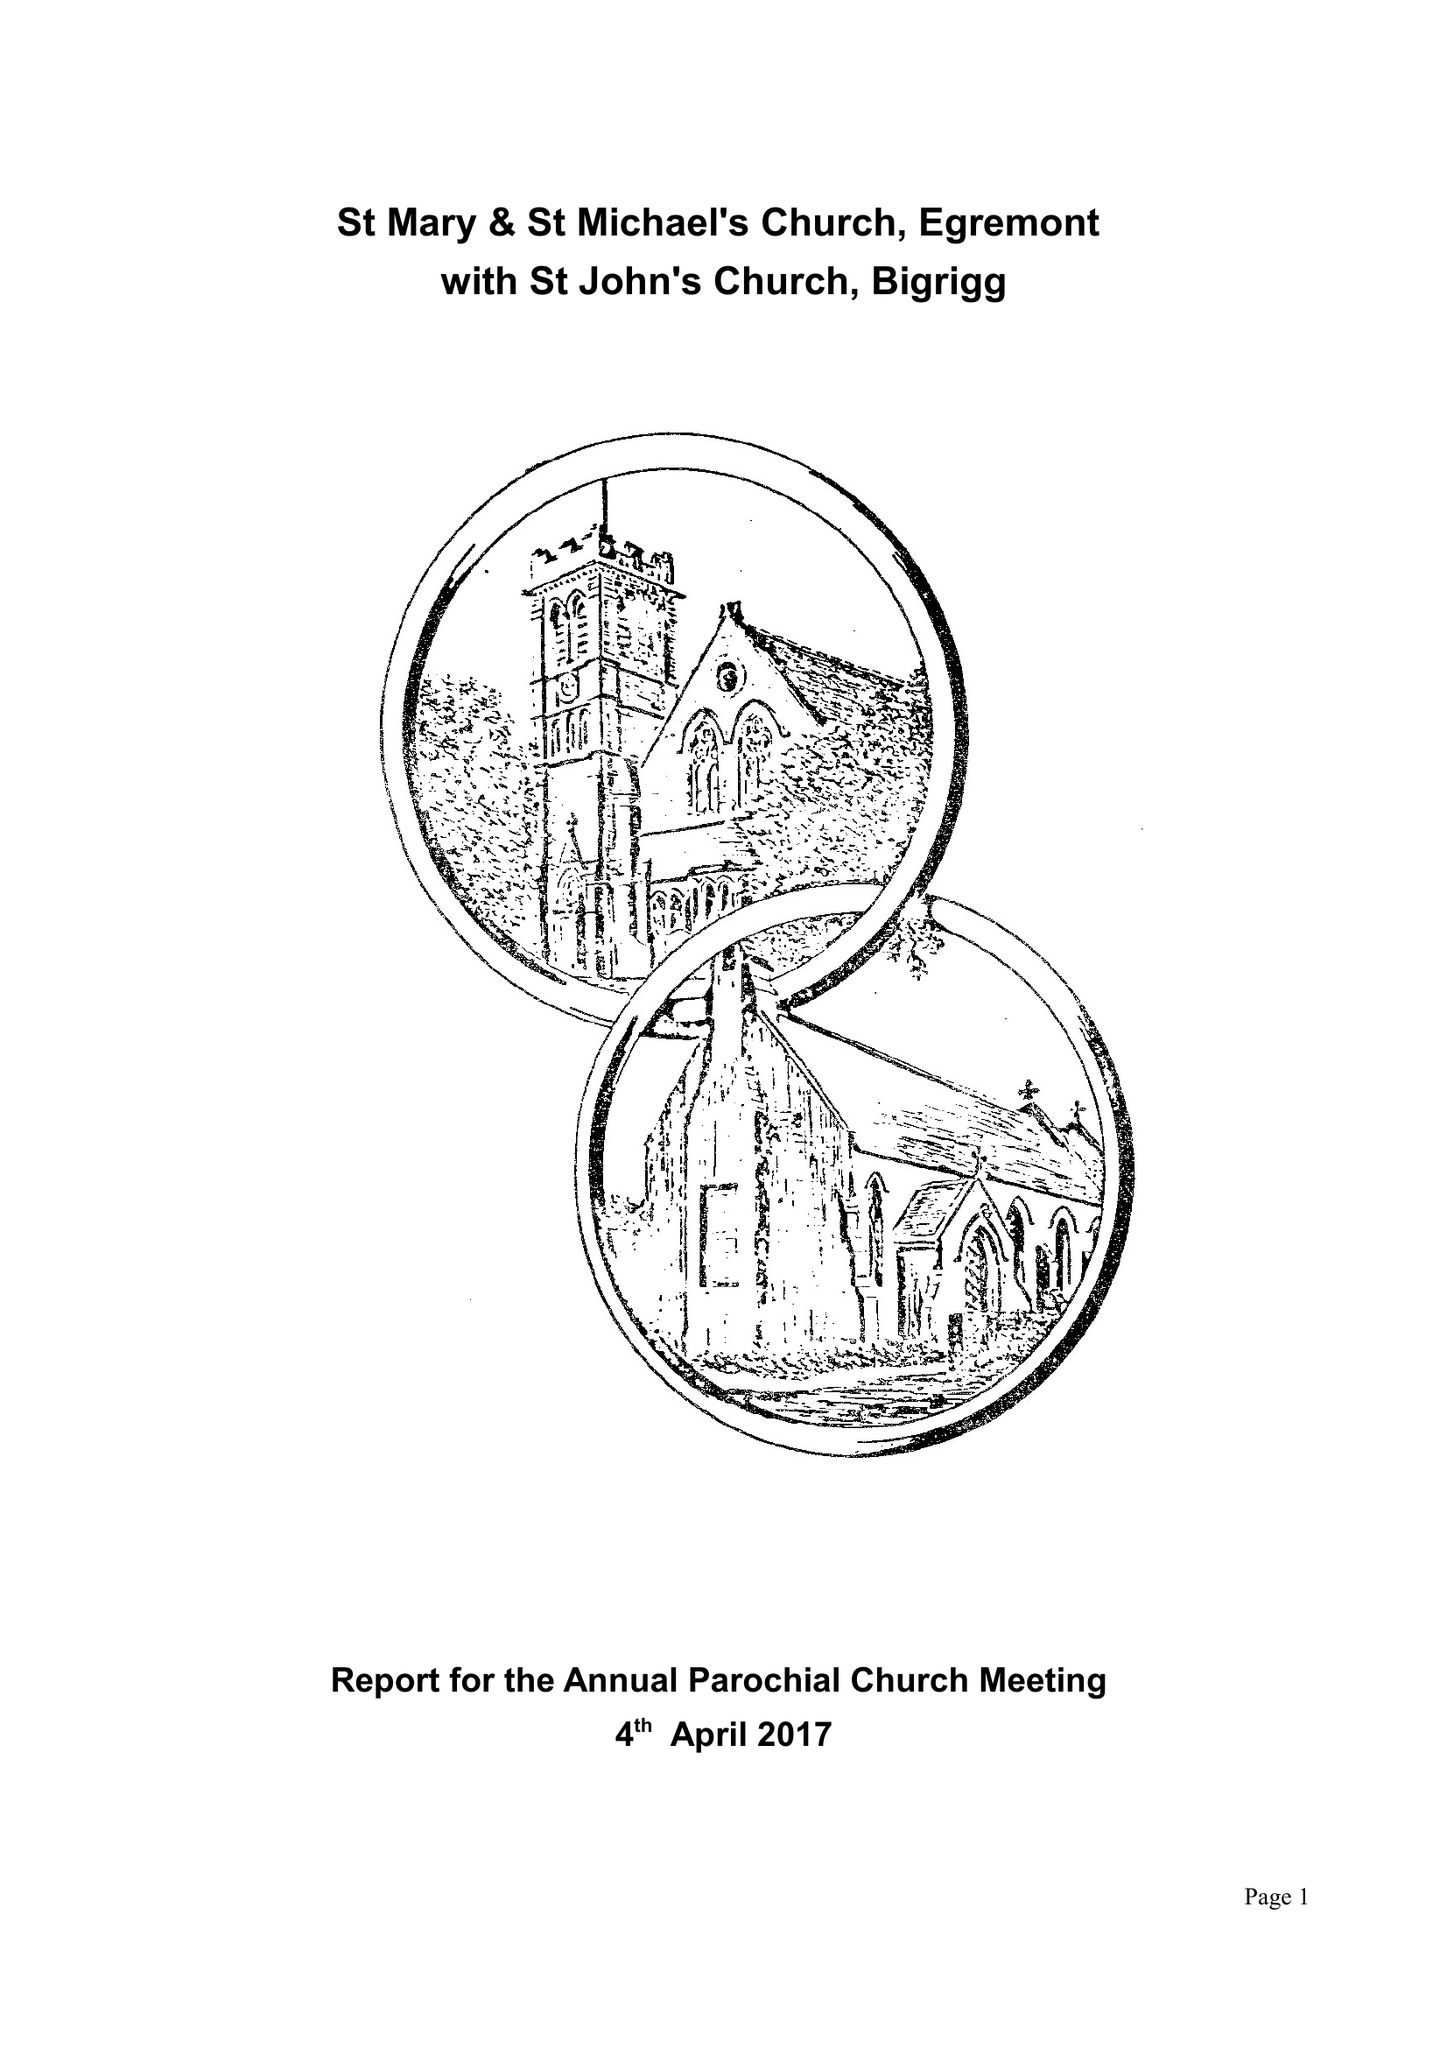What is the value for the address__post_town?
Answer the question using a single word or phrase. EGREMONT 